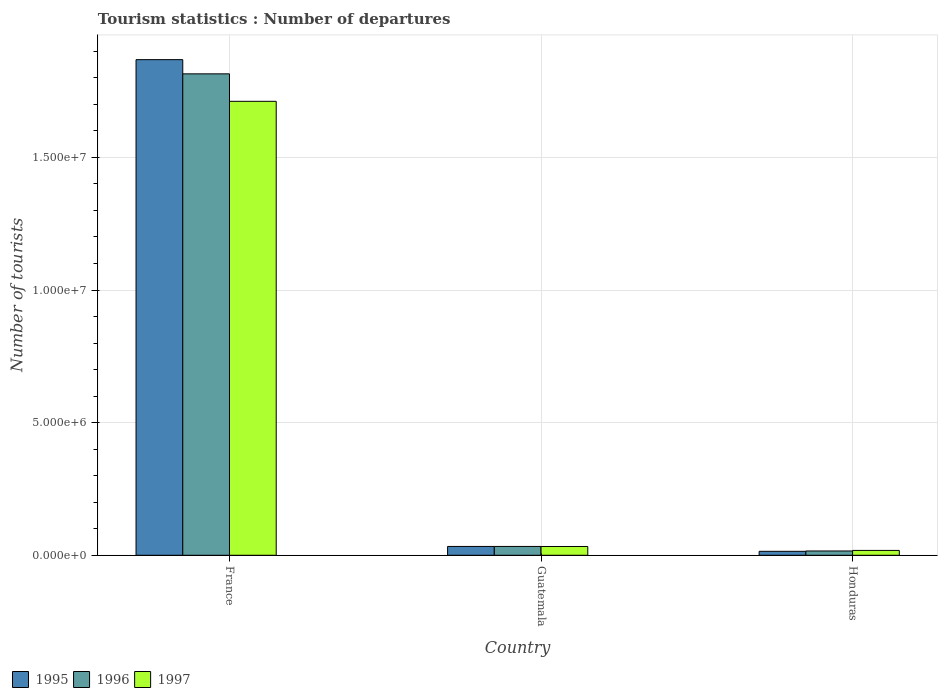Are the number of bars on each tick of the X-axis equal?
Your response must be concise. Yes. How many bars are there on the 1st tick from the left?
Offer a very short reply. 3. How many bars are there on the 2nd tick from the right?
Ensure brevity in your answer.  3. What is the number of tourist departures in 1996 in Guatemala?
Provide a succinct answer. 3.33e+05. Across all countries, what is the maximum number of tourist departures in 1995?
Provide a short and direct response. 1.87e+07. Across all countries, what is the minimum number of tourist departures in 1996?
Ensure brevity in your answer.  1.62e+05. In which country was the number of tourist departures in 1997 minimum?
Provide a short and direct response. Honduras. What is the total number of tourist departures in 1995 in the graph?
Keep it short and to the point. 1.92e+07. What is the difference between the number of tourist departures in 1995 in Guatemala and that in Honduras?
Give a very brief answer. 1.84e+05. What is the difference between the number of tourist departures in 1995 in France and the number of tourist departures in 1996 in Guatemala?
Your answer should be compact. 1.84e+07. What is the average number of tourist departures in 1997 per country?
Provide a succinct answer. 5.88e+06. What is the difference between the number of tourist departures of/in 1996 and number of tourist departures of/in 1995 in Honduras?
Provide a short and direct response. 1.30e+04. What is the ratio of the number of tourist departures in 1997 in France to that in Honduras?
Provide a short and direct response. 93.52. Is the number of tourist departures in 1997 in France less than that in Guatemala?
Give a very brief answer. No. What is the difference between the highest and the second highest number of tourist departures in 1996?
Provide a succinct answer. 1.80e+07. What is the difference between the highest and the lowest number of tourist departures in 1996?
Your answer should be very brief. 1.80e+07. Is the sum of the number of tourist departures in 1995 in France and Honduras greater than the maximum number of tourist departures in 1997 across all countries?
Make the answer very short. Yes. Is it the case that in every country, the sum of the number of tourist departures in 1995 and number of tourist departures in 1996 is greater than the number of tourist departures in 1997?
Your response must be concise. Yes. How many bars are there?
Ensure brevity in your answer.  9. Where does the legend appear in the graph?
Your answer should be compact. Bottom left. What is the title of the graph?
Provide a short and direct response. Tourism statistics : Number of departures. What is the label or title of the Y-axis?
Provide a succinct answer. Number of tourists. What is the Number of tourists of 1995 in France?
Your response must be concise. 1.87e+07. What is the Number of tourists of 1996 in France?
Give a very brief answer. 1.82e+07. What is the Number of tourists in 1997 in France?
Your response must be concise. 1.71e+07. What is the Number of tourists of 1995 in Guatemala?
Provide a short and direct response. 3.33e+05. What is the Number of tourists of 1996 in Guatemala?
Offer a terse response. 3.33e+05. What is the Number of tourists of 1997 in Guatemala?
Make the answer very short. 3.31e+05. What is the Number of tourists in 1995 in Honduras?
Ensure brevity in your answer.  1.49e+05. What is the Number of tourists in 1996 in Honduras?
Offer a terse response. 1.62e+05. What is the Number of tourists in 1997 in Honduras?
Provide a short and direct response. 1.83e+05. Across all countries, what is the maximum Number of tourists in 1995?
Make the answer very short. 1.87e+07. Across all countries, what is the maximum Number of tourists of 1996?
Give a very brief answer. 1.82e+07. Across all countries, what is the maximum Number of tourists of 1997?
Offer a terse response. 1.71e+07. Across all countries, what is the minimum Number of tourists of 1995?
Ensure brevity in your answer.  1.49e+05. Across all countries, what is the minimum Number of tourists of 1996?
Keep it short and to the point. 1.62e+05. Across all countries, what is the minimum Number of tourists of 1997?
Ensure brevity in your answer.  1.83e+05. What is the total Number of tourists in 1995 in the graph?
Give a very brief answer. 1.92e+07. What is the total Number of tourists of 1996 in the graph?
Your answer should be compact. 1.86e+07. What is the total Number of tourists of 1997 in the graph?
Provide a short and direct response. 1.76e+07. What is the difference between the Number of tourists of 1995 in France and that in Guatemala?
Make the answer very short. 1.84e+07. What is the difference between the Number of tourists of 1996 in France and that in Guatemala?
Offer a very short reply. 1.78e+07. What is the difference between the Number of tourists in 1997 in France and that in Guatemala?
Offer a terse response. 1.68e+07. What is the difference between the Number of tourists of 1995 in France and that in Honduras?
Provide a succinct answer. 1.85e+07. What is the difference between the Number of tourists of 1996 in France and that in Honduras?
Give a very brief answer. 1.80e+07. What is the difference between the Number of tourists of 1997 in France and that in Honduras?
Provide a short and direct response. 1.69e+07. What is the difference between the Number of tourists of 1995 in Guatemala and that in Honduras?
Ensure brevity in your answer.  1.84e+05. What is the difference between the Number of tourists in 1996 in Guatemala and that in Honduras?
Offer a very short reply. 1.71e+05. What is the difference between the Number of tourists of 1997 in Guatemala and that in Honduras?
Your response must be concise. 1.48e+05. What is the difference between the Number of tourists of 1995 in France and the Number of tourists of 1996 in Guatemala?
Your answer should be very brief. 1.84e+07. What is the difference between the Number of tourists in 1995 in France and the Number of tourists in 1997 in Guatemala?
Your response must be concise. 1.84e+07. What is the difference between the Number of tourists of 1996 in France and the Number of tourists of 1997 in Guatemala?
Give a very brief answer. 1.78e+07. What is the difference between the Number of tourists of 1995 in France and the Number of tourists of 1996 in Honduras?
Ensure brevity in your answer.  1.85e+07. What is the difference between the Number of tourists of 1995 in France and the Number of tourists of 1997 in Honduras?
Provide a succinct answer. 1.85e+07. What is the difference between the Number of tourists of 1996 in France and the Number of tourists of 1997 in Honduras?
Your response must be concise. 1.80e+07. What is the difference between the Number of tourists in 1995 in Guatemala and the Number of tourists in 1996 in Honduras?
Keep it short and to the point. 1.71e+05. What is the difference between the Number of tourists in 1995 in Guatemala and the Number of tourists in 1997 in Honduras?
Offer a very short reply. 1.50e+05. What is the average Number of tourists of 1995 per country?
Provide a short and direct response. 6.39e+06. What is the average Number of tourists in 1996 per country?
Your response must be concise. 6.22e+06. What is the average Number of tourists of 1997 per country?
Provide a short and direct response. 5.88e+06. What is the difference between the Number of tourists in 1995 and Number of tourists in 1996 in France?
Provide a succinct answer. 5.35e+05. What is the difference between the Number of tourists of 1995 and Number of tourists of 1997 in France?
Make the answer very short. 1.57e+06. What is the difference between the Number of tourists of 1996 and Number of tourists of 1997 in France?
Your answer should be compact. 1.04e+06. What is the difference between the Number of tourists of 1995 and Number of tourists of 1997 in Guatemala?
Ensure brevity in your answer.  2000. What is the difference between the Number of tourists of 1996 and Number of tourists of 1997 in Guatemala?
Ensure brevity in your answer.  2000. What is the difference between the Number of tourists of 1995 and Number of tourists of 1996 in Honduras?
Keep it short and to the point. -1.30e+04. What is the difference between the Number of tourists of 1995 and Number of tourists of 1997 in Honduras?
Make the answer very short. -3.40e+04. What is the difference between the Number of tourists of 1996 and Number of tourists of 1997 in Honduras?
Offer a very short reply. -2.10e+04. What is the ratio of the Number of tourists of 1995 in France to that in Guatemala?
Give a very brief answer. 56.11. What is the ratio of the Number of tourists in 1996 in France to that in Guatemala?
Provide a short and direct response. 54.51. What is the ratio of the Number of tourists of 1997 in France to that in Guatemala?
Provide a succinct answer. 51.71. What is the ratio of the Number of tourists in 1995 in France to that in Honduras?
Give a very brief answer. 125.41. What is the ratio of the Number of tourists in 1996 in France to that in Honduras?
Keep it short and to the point. 112.04. What is the ratio of the Number of tourists of 1997 in France to that in Honduras?
Offer a terse response. 93.52. What is the ratio of the Number of tourists of 1995 in Guatemala to that in Honduras?
Offer a very short reply. 2.23. What is the ratio of the Number of tourists in 1996 in Guatemala to that in Honduras?
Provide a succinct answer. 2.06. What is the ratio of the Number of tourists of 1997 in Guatemala to that in Honduras?
Your response must be concise. 1.81. What is the difference between the highest and the second highest Number of tourists in 1995?
Give a very brief answer. 1.84e+07. What is the difference between the highest and the second highest Number of tourists of 1996?
Provide a succinct answer. 1.78e+07. What is the difference between the highest and the second highest Number of tourists in 1997?
Your response must be concise. 1.68e+07. What is the difference between the highest and the lowest Number of tourists of 1995?
Provide a short and direct response. 1.85e+07. What is the difference between the highest and the lowest Number of tourists in 1996?
Offer a terse response. 1.80e+07. What is the difference between the highest and the lowest Number of tourists in 1997?
Offer a terse response. 1.69e+07. 